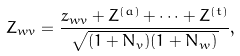<formula> <loc_0><loc_0><loc_500><loc_500>Z _ { w v } = \frac { z _ { w v } + Z ^ { ( a ) } + \cdots + Z ^ { ( t ) } } { \sqrt { ( 1 + N _ { v } ) ( 1 + N _ { w } ) } } ,</formula> 